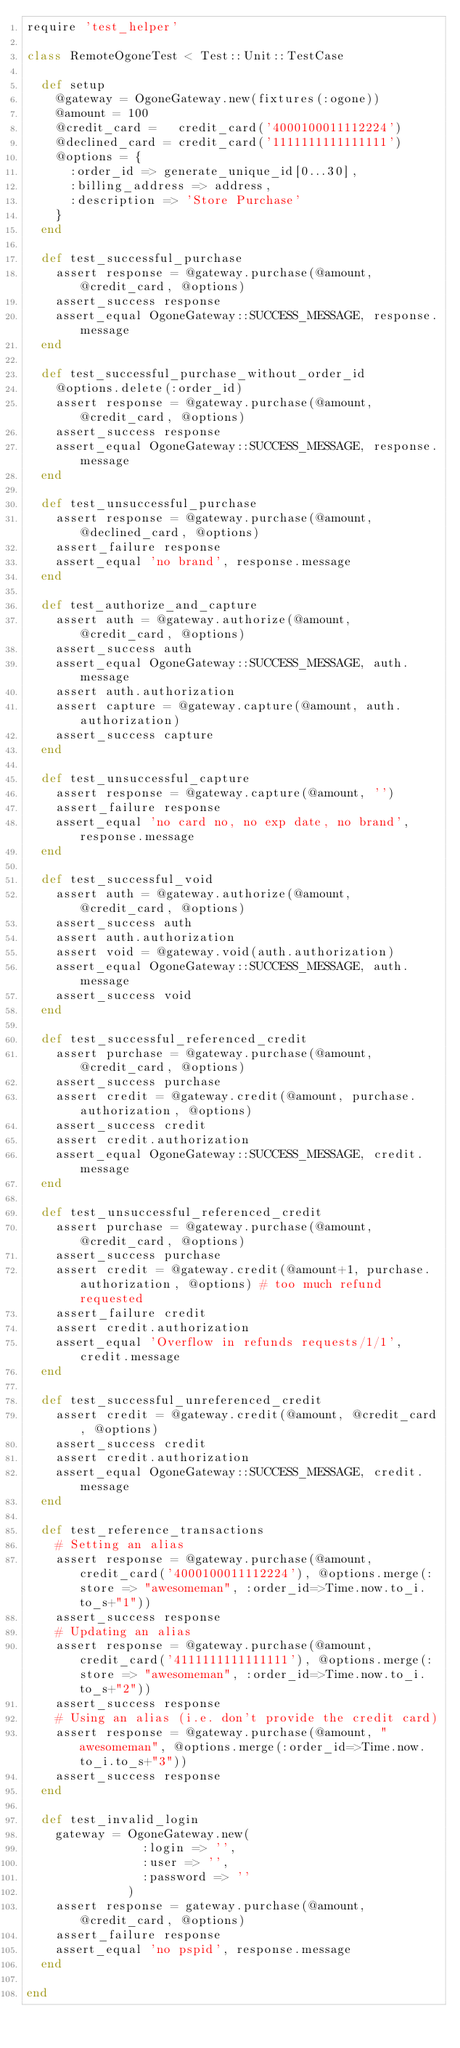Convert code to text. <code><loc_0><loc_0><loc_500><loc_500><_Ruby_>require 'test_helper'

class RemoteOgoneTest < Test::Unit::TestCase

  def setup
    @gateway = OgoneGateway.new(fixtures(:ogone))
    @amount = 100
    @credit_card =   credit_card('4000100011112224')
    @declined_card = credit_card('1111111111111111')
    @options = {
      :order_id => generate_unique_id[0...30],
      :billing_address => address,
      :description => 'Store Purchase'
    }
  end

  def test_successful_purchase
    assert response = @gateway.purchase(@amount, @credit_card, @options)
    assert_success response
    assert_equal OgoneGateway::SUCCESS_MESSAGE, response.message
  end

  def test_successful_purchase_without_order_id
    @options.delete(:order_id)
    assert response = @gateway.purchase(@amount, @credit_card, @options)
    assert_success response
    assert_equal OgoneGateway::SUCCESS_MESSAGE, response.message
  end

  def test_unsuccessful_purchase
    assert response = @gateway.purchase(@amount, @declined_card, @options)
    assert_failure response
    assert_equal 'no brand', response.message
  end

  def test_authorize_and_capture
    assert auth = @gateway.authorize(@amount, @credit_card, @options)
    assert_success auth
    assert_equal OgoneGateway::SUCCESS_MESSAGE, auth.message
    assert auth.authorization
    assert capture = @gateway.capture(@amount, auth.authorization)
    assert_success capture
  end

  def test_unsuccessful_capture
    assert response = @gateway.capture(@amount, '')
    assert_failure response
    assert_equal 'no card no, no exp date, no brand', response.message
  end

  def test_successful_void
    assert auth = @gateway.authorize(@amount, @credit_card, @options)
    assert_success auth
    assert auth.authorization
    assert void = @gateway.void(auth.authorization)
    assert_equal OgoneGateway::SUCCESS_MESSAGE, auth.message
    assert_success void
  end

  def test_successful_referenced_credit
    assert purchase = @gateway.purchase(@amount, @credit_card, @options)
    assert_success purchase
    assert credit = @gateway.credit(@amount, purchase.authorization, @options)
    assert_success credit
    assert credit.authorization
    assert_equal OgoneGateway::SUCCESS_MESSAGE, credit.message
  end

  def test_unsuccessful_referenced_credit
    assert purchase = @gateway.purchase(@amount, @credit_card, @options)
    assert_success purchase
    assert credit = @gateway.credit(@amount+1, purchase.authorization, @options) # too much refund requested
    assert_failure credit
    assert credit.authorization
    assert_equal 'Overflow in refunds requests/1/1', credit.message
  end

  def test_successful_unreferenced_credit
    assert credit = @gateway.credit(@amount, @credit_card, @options)
    assert_success credit
    assert credit.authorization
    assert_equal OgoneGateway::SUCCESS_MESSAGE, credit.message
  end

  def test_reference_transactions
    # Setting an alias
    assert response = @gateway.purchase(@amount, credit_card('4000100011112224'), @options.merge(:store => "awesomeman", :order_id=>Time.now.to_i.to_s+"1"))
    assert_success response
    # Updating an alias
    assert response = @gateway.purchase(@amount, credit_card('4111111111111111'), @options.merge(:store => "awesomeman", :order_id=>Time.now.to_i.to_s+"2"))
    assert_success response
    # Using an alias (i.e. don't provide the credit card)
    assert response = @gateway.purchase(@amount, "awesomeman", @options.merge(:order_id=>Time.now.to_i.to_s+"3"))
    assert_success response
  end

  def test_invalid_login
    gateway = OgoneGateway.new(
                :login => '',
                :user => '',
                :password => ''
              )
    assert response = gateway.purchase(@amount, @credit_card, @options)
    assert_failure response
    assert_equal 'no pspid', response.message
  end

end</code> 